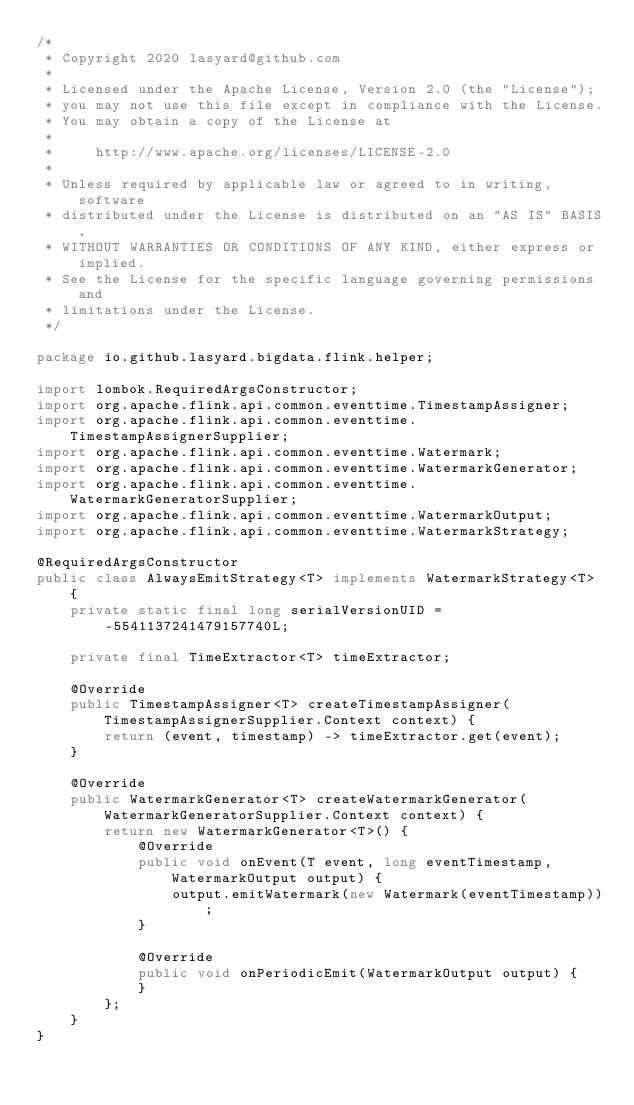<code> <loc_0><loc_0><loc_500><loc_500><_Java_>/*
 * Copyright 2020 lasyard@github.com
 *
 * Licensed under the Apache License, Version 2.0 (the "License");
 * you may not use this file except in compliance with the License.
 * You may obtain a copy of the License at
 *
 *     http://www.apache.org/licenses/LICENSE-2.0
 *
 * Unless required by applicable law or agreed to in writing, software
 * distributed under the License is distributed on an "AS IS" BASIS,
 * WITHOUT WARRANTIES OR CONDITIONS OF ANY KIND, either express or implied.
 * See the License for the specific language governing permissions and
 * limitations under the License.
 */

package io.github.lasyard.bigdata.flink.helper;

import lombok.RequiredArgsConstructor;
import org.apache.flink.api.common.eventtime.TimestampAssigner;
import org.apache.flink.api.common.eventtime.TimestampAssignerSupplier;
import org.apache.flink.api.common.eventtime.Watermark;
import org.apache.flink.api.common.eventtime.WatermarkGenerator;
import org.apache.flink.api.common.eventtime.WatermarkGeneratorSupplier;
import org.apache.flink.api.common.eventtime.WatermarkOutput;
import org.apache.flink.api.common.eventtime.WatermarkStrategy;

@RequiredArgsConstructor
public class AlwaysEmitStrategy<T> implements WatermarkStrategy<T> {
    private static final long serialVersionUID = -5541137241479157740L;

    private final TimeExtractor<T> timeExtractor;

    @Override
    public TimestampAssigner<T> createTimestampAssigner(TimestampAssignerSupplier.Context context) {
        return (event, timestamp) -> timeExtractor.get(event);
    }

    @Override
    public WatermarkGenerator<T> createWatermarkGenerator(WatermarkGeneratorSupplier.Context context) {
        return new WatermarkGenerator<T>() {
            @Override
            public void onEvent(T event, long eventTimestamp, WatermarkOutput output) {
                output.emitWatermark(new Watermark(eventTimestamp));
            }

            @Override
            public void onPeriodicEmit(WatermarkOutput output) {
            }
        };
    }
}
</code> 